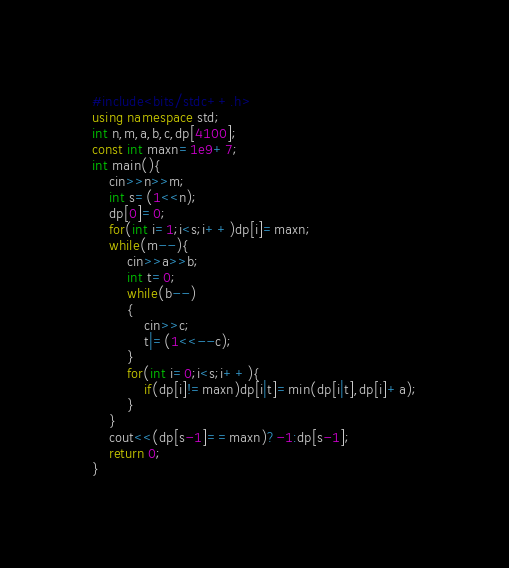Convert code to text. <code><loc_0><loc_0><loc_500><loc_500><_C++_>#include<bits/stdc++.h> 
using namespace std;
int n,m,a,b,c,dp[4100];
const int maxn=1e9+7;
int main(){
	cin>>n>>m;
	int s=(1<<n);
	dp[0]=0;
	for(int i=1;i<s;i++)dp[i]=maxn;
	while(m--){
		cin>>a>>b;
		int t=0;
		while(b--)
		{
			cin>>c;
			t|=(1<<--c);
		}
		for(int i=0;i<s;i++){
			if(dp[i]!=maxn)dp[i|t]=min(dp[i|t],dp[i]+a);
		}	
	}
	cout<<(dp[s-1]==maxn)?-1:dp[s-1];
	return 0;
}</code> 